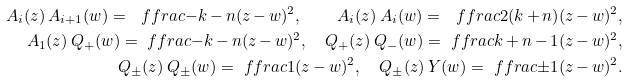Convert formula to latex. <formula><loc_0><loc_0><loc_500><loc_500>A _ { i } ( z ) \, A _ { i + 1 } ( w ) = \ f f r a c { - k \, { - } \, n } { ( z \, { - } \, w ) ^ { 2 } } , \quad A _ { i } ( z ) \, A _ { i } ( w ) = \ f f r a c { 2 ( k \, { + } \, n ) } { ( z \, { - } \, w ) ^ { 2 } } , \\ A _ { 1 } ( z ) \, Q _ { + } ( w ) = \ f f r a c { - k \, { - } \, n } { ( z \, { - } \, w ) ^ { 2 } } , \quad Q _ { + } ( z ) \, Q _ { - } ( w ) = \ f f r a c { k \, { + } \, n \, { - } \, 1 } { ( z \, { - } \, w ) ^ { 2 } } , \\ Q _ { \pm } ( z ) \, Q _ { \pm } ( w ) = \ f f r a c { 1 } { ( z \, { - } \, w ) ^ { 2 } } , \quad Q _ { \pm } ( z ) \, Y ( w ) = \ f f r a c { \pm 1 } { ( z \, { - } \, w ) ^ { 2 } } .</formula> 